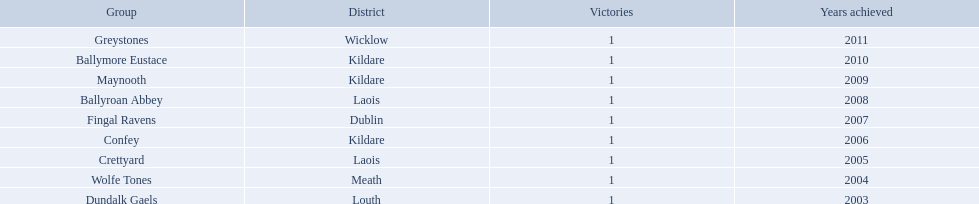What county is ballymore eustace from? Kildare. Besides convey, which other team is from the same county? Maynooth. Where is ballymore eustace from? Kildare. What teams other than ballymore eustace is from kildare? Maynooth, Confey. Parse the full table. {'header': ['Group', 'District', 'Victories', 'Years achieved'], 'rows': [['Greystones', 'Wicklow', '1', '2011'], ['Ballymore Eustace', 'Kildare', '1', '2010'], ['Maynooth', 'Kildare', '1', '2009'], ['Ballyroan Abbey', 'Laois', '1', '2008'], ['Fingal Ravens', 'Dublin', '1', '2007'], ['Confey', 'Kildare', '1', '2006'], ['Crettyard', 'Laois', '1', '2005'], ['Wolfe Tones', 'Meath', '1', '2004'], ['Dundalk Gaels', 'Louth', '1', '2003']]} Between maynooth and confey, which won in 2009? Maynooth. 